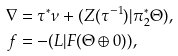<formula> <loc_0><loc_0><loc_500><loc_500>\nabla & = \tau ^ { * } \nu + ( Z ( \tau ^ { - 1 } ) | \pi _ { 2 } ^ { * } \Theta ) , \\ f & = - ( L | F ( \Theta \oplus 0 ) ) ,</formula> 